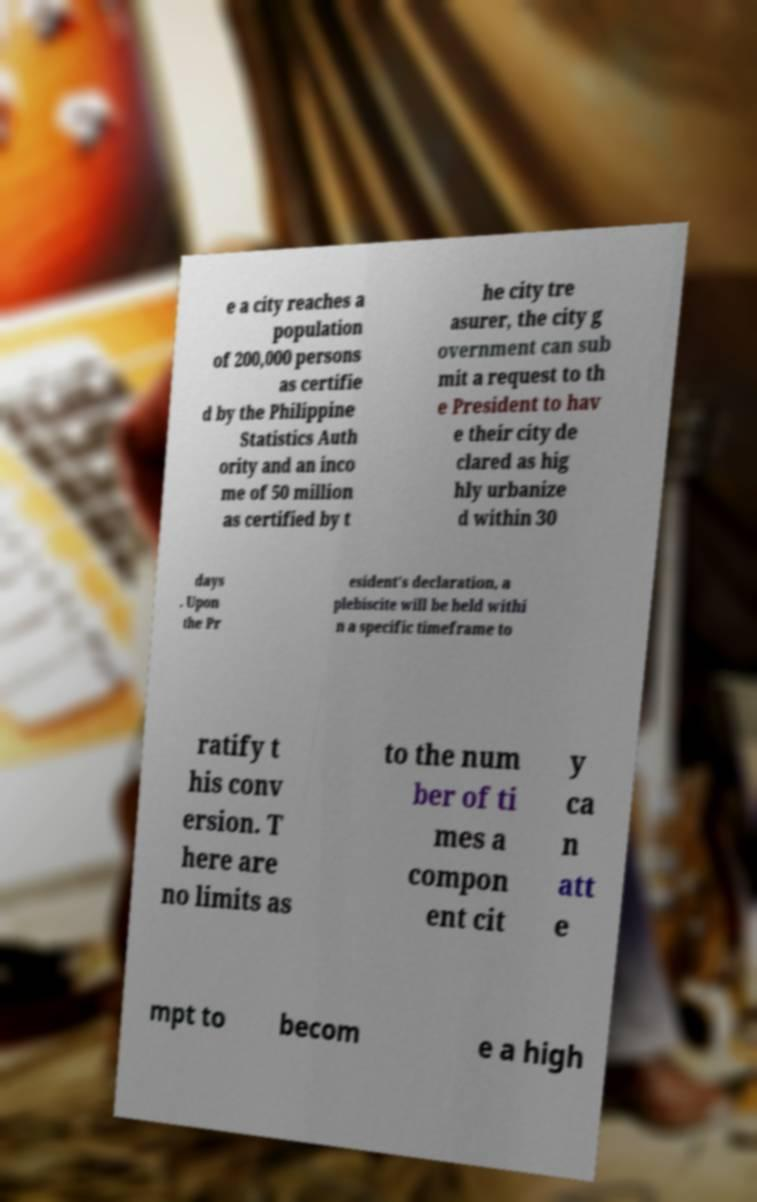What messages or text are displayed in this image? I need them in a readable, typed format. e a city reaches a population of 200,000 persons as certifie d by the Philippine Statistics Auth ority and an inco me of 50 million as certified by t he city tre asurer, the city g overnment can sub mit a request to th e President to hav e their city de clared as hig hly urbanize d within 30 days . Upon the Pr esident's declaration, a plebiscite will be held withi n a specific timeframe to ratify t his conv ersion. T here are no limits as to the num ber of ti mes a compon ent cit y ca n att e mpt to becom e a high 